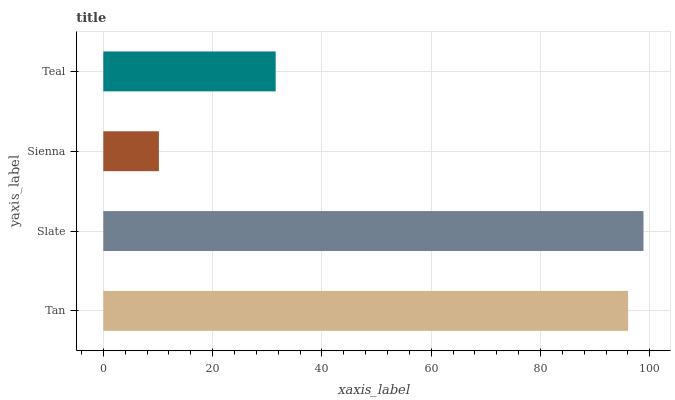Is Sienna the minimum?
Answer yes or no. Yes. Is Slate the maximum?
Answer yes or no. Yes. Is Slate the minimum?
Answer yes or no. No. Is Sienna the maximum?
Answer yes or no. No. Is Slate greater than Sienna?
Answer yes or no. Yes. Is Sienna less than Slate?
Answer yes or no. Yes. Is Sienna greater than Slate?
Answer yes or no. No. Is Slate less than Sienna?
Answer yes or no. No. Is Tan the high median?
Answer yes or no. Yes. Is Teal the low median?
Answer yes or no. Yes. Is Slate the high median?
Answer yes or no. No. Is Sienna the low median?
Answer yes or no. No. 